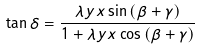<formula> <loc_0><loc_0><loc_500><loc_500>\tan { \delta } = \frac { \lambda y x \sin { ( \beta + \gamma ) } } { 1 + \lambda y x \cos { ( \beta + \gamma ) } }</formula> 